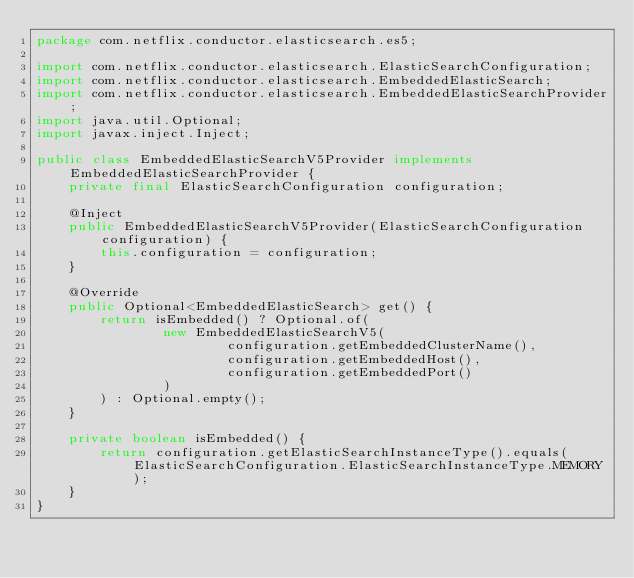Convert code to text. <code><loc_0><loc_0><loc_500><loc_500><_Java_>package com.netflix.conductor.elasticsearch.es5;

import com.netflix.conductor.elasticsearch.ElasticSearchConfiguration;
import com.netflix.conductor.elasticsearch.EmbeddedElasticSearch;
import com.netflix.conductor.elasticsearch.EmbeddedElasticSearchProvider;
import java.util.Optional;
import javax.inject.Inject;

public class EmbeddedElasticSearchV5Provider implements EmbeddedElasticSearchProvider {
    private final ElasticSearchConfiguration configuration;

    @Inject
    public EmbeddedElasticSearchV5Provider(ElasticSearchConfiguration configuration) {
        this.configuration = configuration;
    }

    @Override
    public Optional<EmbeddedElasticSearch> get() {
        return isEmbedded() ? Optional.of(
                new EmbeddedElasticSearchV5(
                        configuration.getEmbeddedClusterName(),
                        configuration.getEmbeddedHost(),
                        configuration.getEmbeddedPort()
                )
        ) : Optional.empty();
    }

    private boolean isEmbedded() {
        return configuration.getElasticSearchInstanceType().equals(ElasticSearchConfiguration.ElasticSearchInstanceType.MEMORY);
    }
}
</code> 